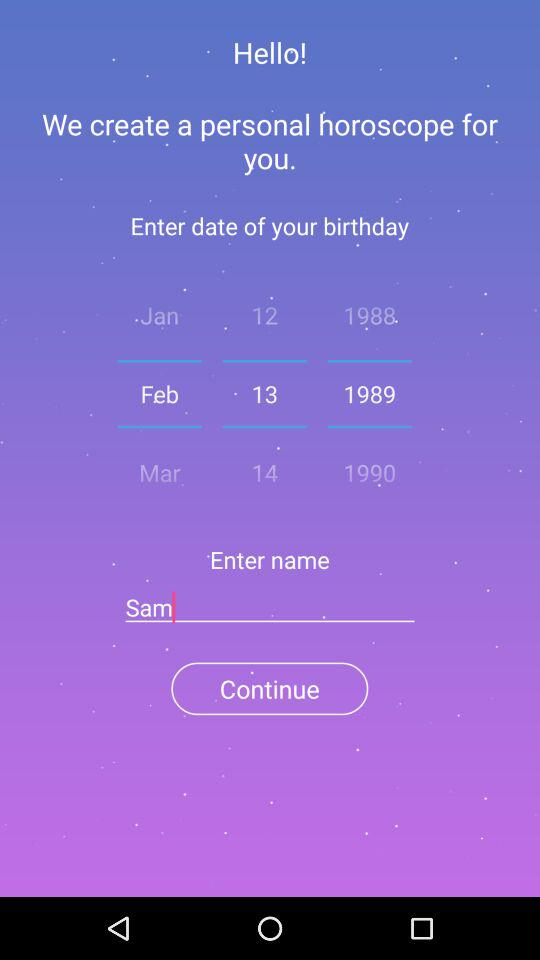What is the entered name? The entered name is Sam. 